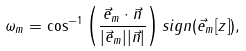Convert formula to latex. <formula><loc_0><loc_0><loc_500><loc_500>\omega _ { m } = \cos ^ { - 1 } \left ( \frac { \vec { e } _ { m } \cdot \vec { n } } { | \vec { e } _ { m } | | \vec { n } | } \right ) s i g n ( \vec { e } _ { m } [ z ] ) ,</formula> 